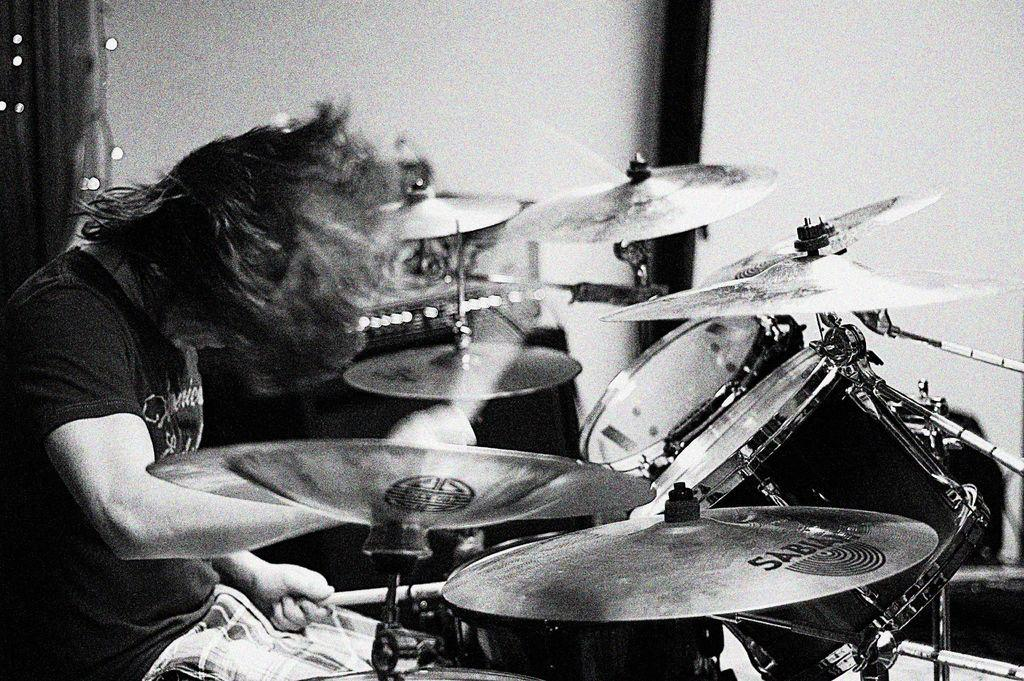What is the color scheme of the image? The image is black and white. Can you describe the main subject in the image? There is a person in the image. Where is the person located in the image? The person is on the left side of the image. What objects are in front of the person? There are drums in front of the person. What is the person doing in the image? The person is playing the drums. What type of fuel is being used by the person to play the drums in the image? There is no mention of fuel in the image, as the person is playing drums, which do not require fuel. 